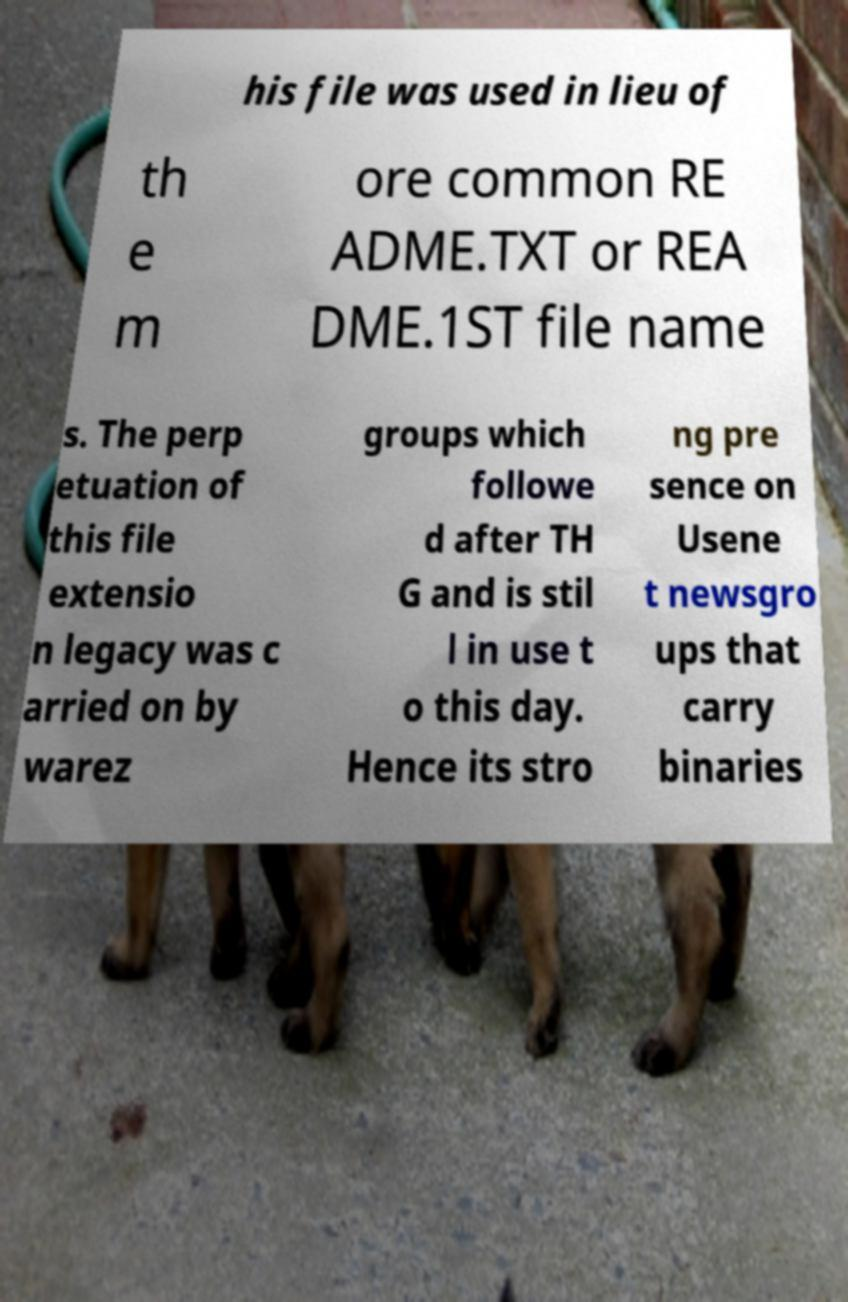There's text embedded in this image that I need extracted. Can you transcribe it verbatim? his file was used in lieu of th e m ore common RE ADME.TXT or REA DME.1ST file name s. The perp etuation of this file extensio n legacy was c arried on by warez groups which followe d after TH G and is stil l in use t o this day. Hence its stro ng pre sence on Usene t newsgro ups that carry binaries 